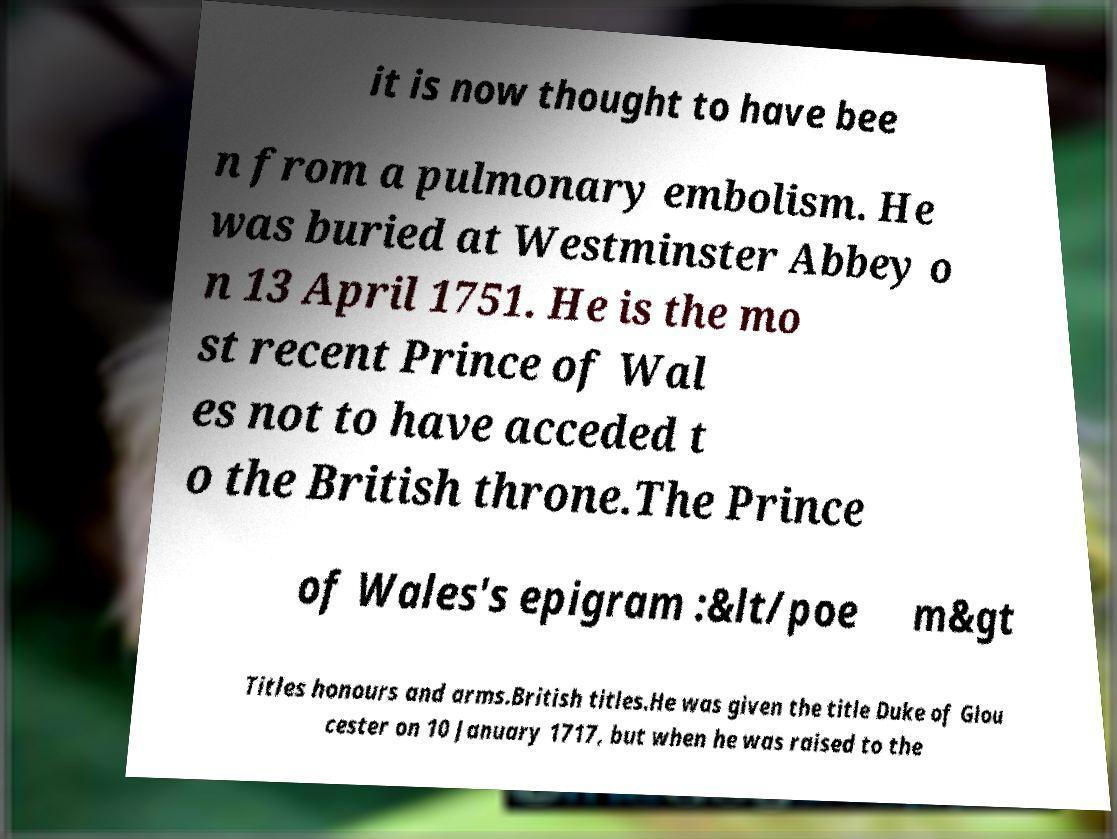Could you assist in decoding the text presented in this image and type it out clearly? it is now thought to have bee n from a pulmonary embolism. He was buried at Westminster Abbey o n 13 April 1751. He is the mo st recent Prince of Wal es not to have acceded t o the British throne.The Prince of Wales's epigram :&lt/poe m&gt Titles honours and arms.British titles.He was given the title Duke of Glou cester on 10 January 1717, but when he was raised to the 